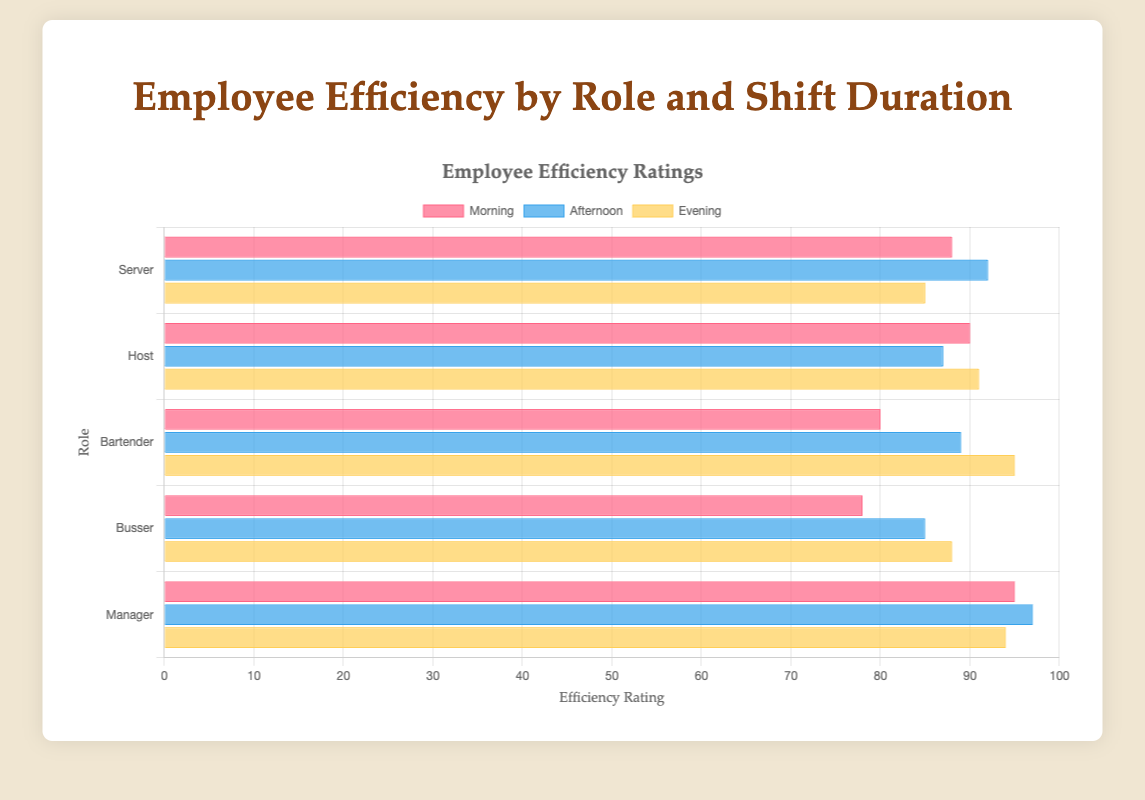What is the average efficiency rating of servers across all shifts? To find the average efficiency rating of servers, sum their ratings for morning, afternoon, and evening shifts: 88 + 92 + 85 = 265, then divide by the number of shifts (3): 265 / 3 ≈ 88.33
Answer: 88.33 Which role has the highest efficiency rating in the evening shift? Look at the efficiency ratings for the evening shift across all roles. The roles and ratings are Server (85), Host (91), Bartender (95), Busser (88), and Manager (94). The highest rating is 95, belonging to the Bartender role.
Answer: Bartender Which shift duration shows the highest efficiency rating for Michael Wilson? Examine Michael Wilson's efficiency ratings for each shift duration: Morning (95), Afternoon (97), and Evening (94). The highest rating is 97, which is in the afternoon shift.
Answer: Afternoon Which role has the lowest efficiency rating in the morning shift? Compare the morning shift efficiency ratings for all roles: Server (88), Host (90), Bartender (80), Busser (78), and Manager (95). The lowest rating is 78, belonging to the Busser role.
Answer: Busser How much higher is Emily Davis's efficiency rating in the evening shift compared to the afternoon shift? Subtract Emily Davis's efficiency rating in the afternoon shift (85) from her evening shift rating (88): 88 - 85 = 3.
Answer: 3 Among the hosts, how much does the evening shift efficiency rating differ from the morning shift efficiency rating? Compare the Host's efficiency ratings for the evening (91) and morning (90) shifts by subtracting the morning rating from the evening rating: 91 - 90 = 1.
Answer: 1 Which shift duration has the smallest variation in efficiency ratings across all roles? Calculate the range for each shift by finding the difference between the highest and lowest ratings in each shift: 
- Morning: 95 (Manager) - 78 (Busser) = 17
- Afternoon: 97 (Manager) - 85 (Busser) = 12
- Evening: 95 (Bartender) - 85 (Server) = 10
The smallest variation is in the evening shift (10).
Answer: Evening Who has the highest overall efficiency rating among all employees? Identify the highest single efficiency rating across all employees and shifts. The highest rating is Michael Wilson in the afternoon shift with 97.
Answer: Michael Wilson What is the total sum of efficiency ratings for all bartenders across all shifts? Add up the efficiency ratings for Bartender across morning, afternoon, and evening: 80 + 89 + 95 = 264.
Answer: 264 Comparing servers and bussers, which role has a higher efficiency rating in the evening and by how much? Compare the evening shift efficiency ratings: Server (85) and Busser (88). Subtract the Server rating from the Busser rating: 88 - 85 = 3.
Answer: Busser by 3 